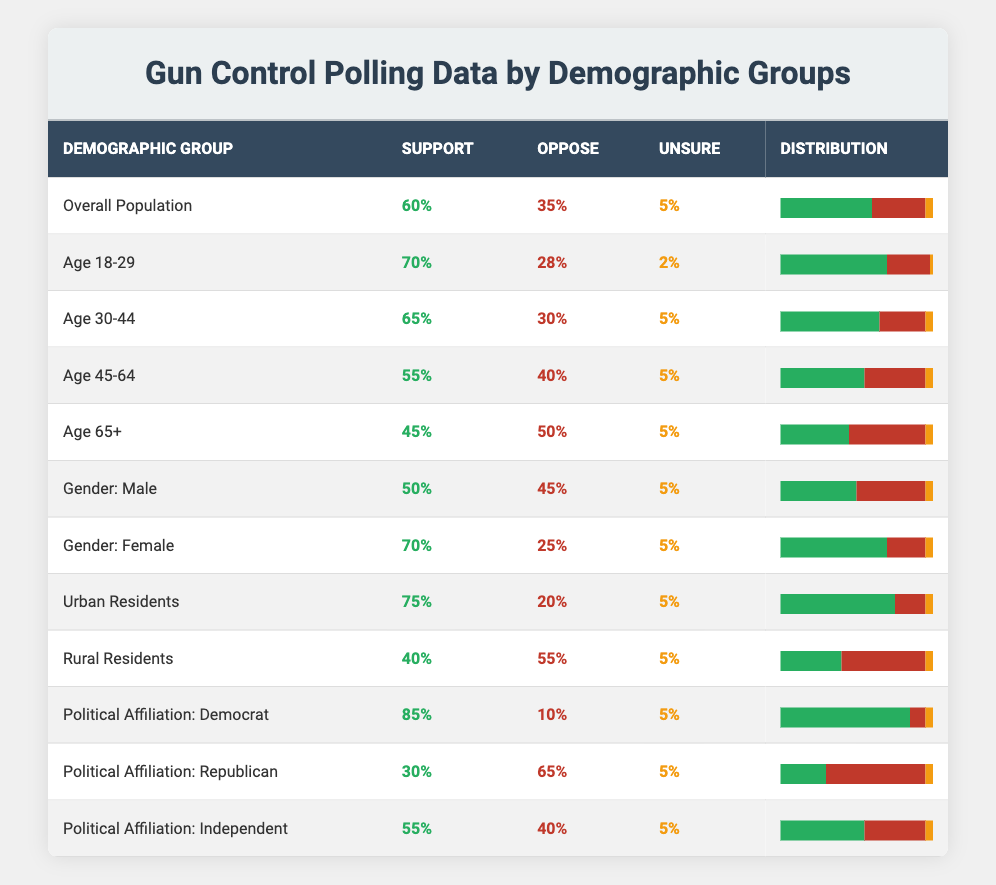What is the support percentage for urban residents? The support percentage for urban residents is directly stated in the table under the "Support" column for the "Urban Residents" row, which shows 75%.
Answer: 75% What is the opposition percentage among rural residents? The opposition percentage among rural residents can be found in the "Oppose" column for the "Rural Residents" row, which indicates 55%.
Answer: 55% Which demographic group has the highest support for gun control measures? By scanning through the "Support" column, "Political Affiliation: Democrat" has the highest percentage at 85%.
Answer: 85% What is the difference in support percentage between males and females? The support percentage for males is 50% and for females is 70%. The difference can be calculated as 70% - 50% = 20%.
Answer: 20% Is it true that the majority of individuals aged 65 and above oppose gun control measures? In the table, the "Oppose" percentage for the "Age 65+" group is 50%, which is indeed greater than their "Support" percentage of 45%. Therefore, it is true.
Answer: Yes What is the average support percentage for the age groups (18-29, 30-44, 45-64, and 65+)? The support percentages for the age groups are 70%, 65%, 55%, and 45%. Adding these up gives 70 + 65 + 55 + 45 = 235. There are 4 age groups, so the average is 235/4 = 58.75%.
Answer: 58.75% Which demographic group has the least percentage of individuals unsure about gun control? The "Unsure" percentage for all demographic groups is consistently 5%, making it the least for every group. However, it can be confirmed by checking the "Unsure" column for all demographics.
Answer: 5% Does a higher percentage of females support gun control compared to the overall population? The support percentage for females is 70% while the overall population's support percentage is 60%. Since 70% is greater than 60%, the statement is true.
Answer: Yes What is the combined support percentage for Independents and Urban Residents? The support percentages are 55% for Independents and 75% for Urban Residents. The combined total is 55% + 75% = 130%.
Answer: 130% 